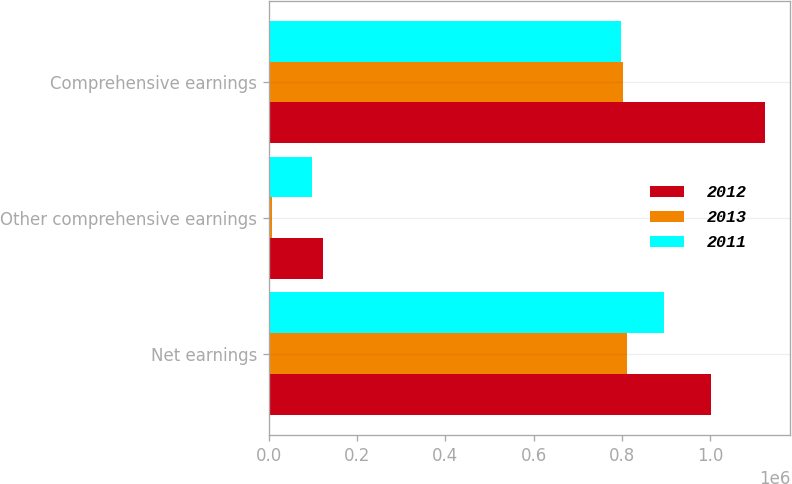Convert chart to OTSL. <chart><loc_0><loc_0><loc_500><loc_500><stacked_bar_chart><ecel><fcel>Net earnings<fcel>Other comprehensive earnings<fcel>Comprehensive earnings<nl><fcel>2012<fcel>1.00313e+06<fcel>122629<fcel>1.12576e+06<nl><fcel>2013<fcel>811070<fcel>7396<fcel>803674<nl><fcel>2011<fcel>895243<fcel>97671<fcel>797572<nl></chart> 